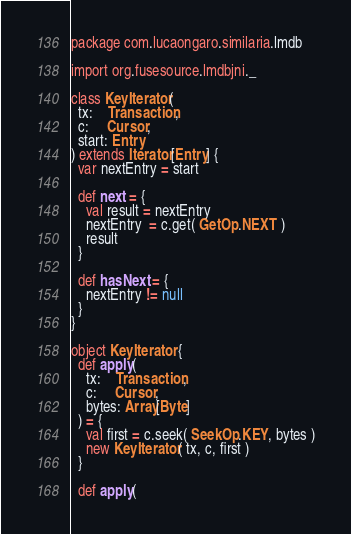Convert code to text. <code><loc_0><loc_0><loc_500><loc_500><_Scala_>package com.lucaongaro.similaria.lmdb

import org.fusesource.lmdbjni._

class KeyIterator(
  tx:    Transaction,
  c:     Cursor,
  start: Entry
) extends Iterator[Entry] {
  var nextEntry = start

  def next = {
    val result = nextEntry
    nextEntry  = c.get( GetOp.NEXT )
    result
  }

  def hasNext = {
    nextEntry != null
  }
}

object KeyIterator {
  def apply(
    tx:    Transaction,
    c:     Cursor,
    bytes: Array[Byte]
  ) = {
    val first = c.seek( SeekOp.KEY, bytes )
    new KeyIterator( tx, c, first )
  }

  def apply(</code> 